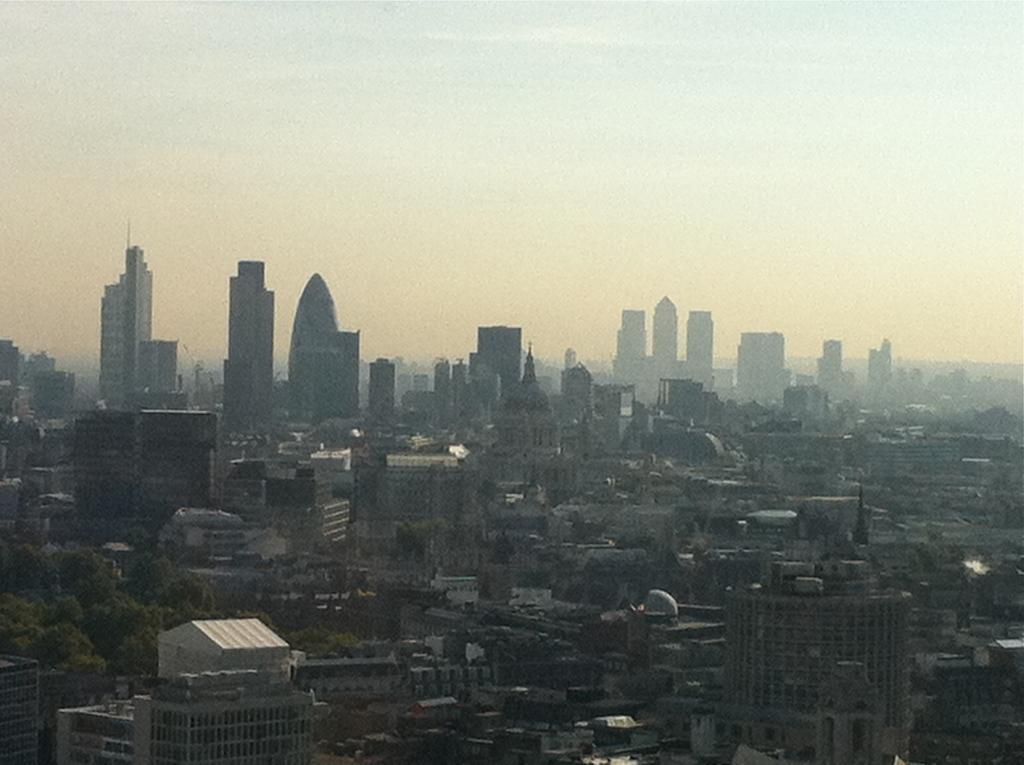What type of structures can be seen in the image? There are many buildings in the image. What other natural elements are present in the image? There are trees in the image. What part of the natural environment is visible in the image? The sky is visible in the image. What type of weather condition is depicted in the image? The image does not depict any specific weather condition, as it only shows buildings, trees, and the sky. How many clocks can be seen in the image? There are no clocks present in the image. 